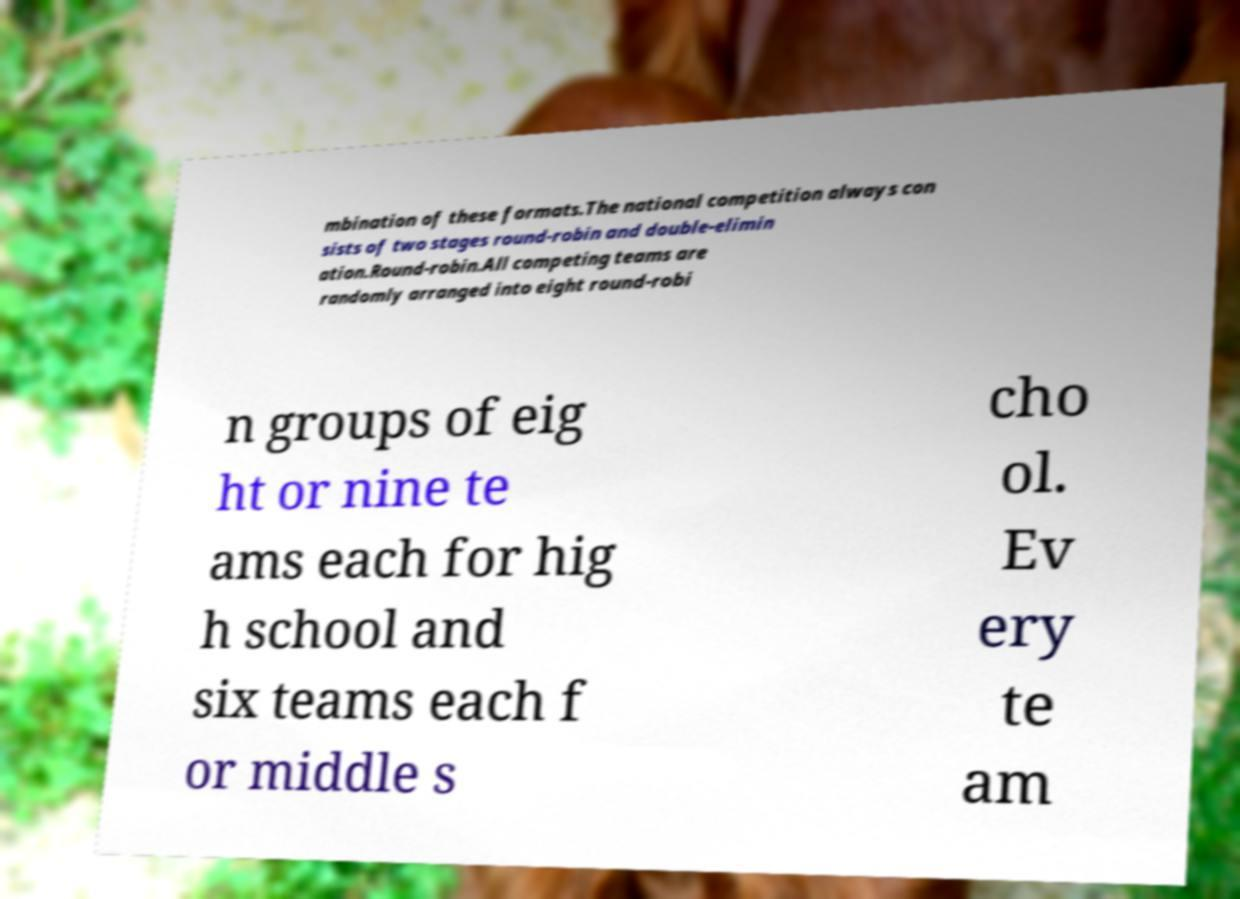Could you extract and type out the text from this image? mbination of these formats.The national competition always con sists of two stages round-robin and double-elimin ation.Round-robin.All competing teams are randomly arranged into eight round-robi n groups of eig ht or nine te ams each for hig h school and six teams each f or middle s cho ol. Ev ery te am 